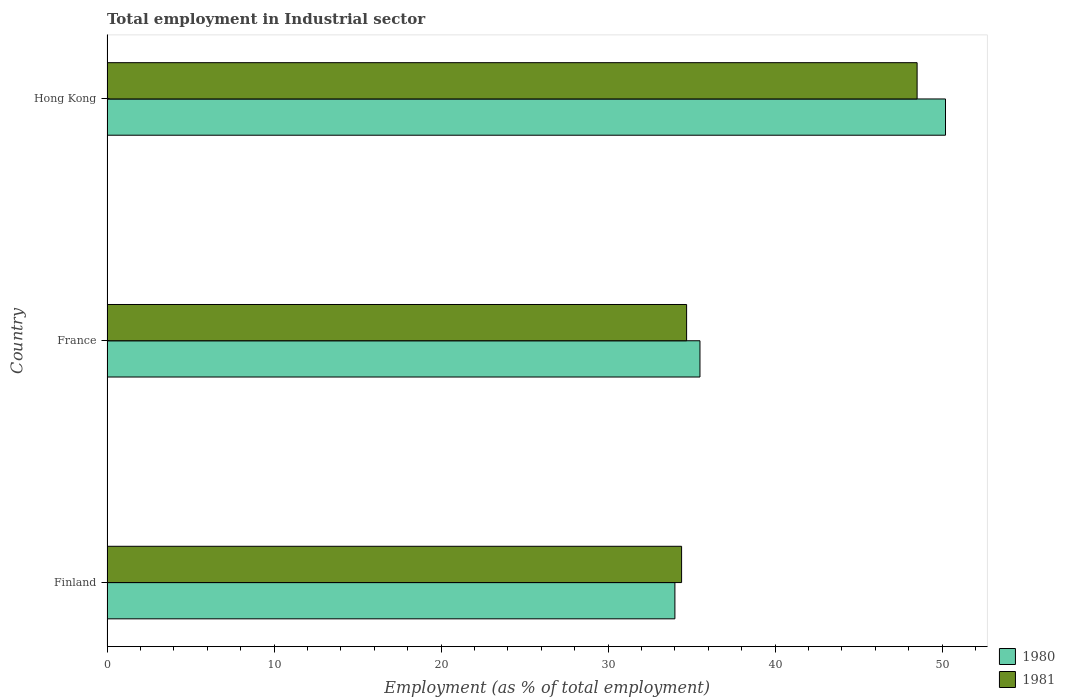How many different coloured bars are there?
Keep it short and to the point. 2. How many groups of bars are there?
Keep it short and to the point. 3. Are the number of bars per tick equal to the number of legend labels?
Ensure brevity in your answer.  Yes. Are the number of bars on each tick of the Y-axis equal?
Keep it short and to the point. Yes. How many bars are there on the 3rd tick from the top?
Make the answer very short. 2. What is the employment in industrial sector in 1981 in France?
Ensure brevity in your answer.  34.7. Across all countries, what is the maximum employment in industrial sector in 1980?
Provide a short and direct response. 50.2. Across all countries, what is the minimum employment in industrial sector in 1981?
Give a very brief answer. 34.4. In which country was the employment in industrial sector in 1981 maximum?
Your response must be concise. Hong Kong. In which country was the employment in industrial sector in 1981 minimum?
Provide a short and direct response. Finland. What is the total employment in industrial sector in 1980 in the graph?
Give a very brief answer. 119.7. What is the difference between the employment in industrial sector in 1980 in Finland and that in Hong Kong?
Offer a terse response. -16.2. What is the difference between the employment in industrial sector in 1981 in Hong Kong and the employment in industrial sector in 1980 in France?
Provide a short and direct response. 13. What is the average employment in industrial sector in 1981 per country?
Give a very brief answer. 39.2. What is the difference between the employment in industrial sector in 1981 and employment in industrial sector in 1980 in Hong Kong?
Give a very brief answer. -1.7. What is the ratio of the employment in industrial sector in 1981 in France to that in Hong Kong?
Provide a short and direct response. 0.72. Is the employment in industrial sector in 1980 in Finland less than that in Hong Kong?
Ensure brevity in your answer.  Yes. What is the difference between the highest and the second highest employment in industrial sector in 1981?
Your answer should be very brief. 13.8. What is the difference between the highest and the lowest employment in industrial sector in 1980?
Your response must be concise. 16.2. Is the sum of the employment in industrial sector in 1980 in Finland and Hong Kong greater than the maximum employment in industrial sector in 1981 across all countries?
Your answer should be compact. Yes. What does the 1st bar from the bottom in Hong Kong represents?
Offer a very short reply. 1980. How many bars are there?
Ensure brevity in your answer.  6. Are all the bars in the graph horizontal?
Make the answer very short. Yes. Where does the legend appear in the graph?
Keep it short and to the point. Bottom right. How many legend labels are there?
Your response must be concise. 2. How are the legend labels stacked?
Keep it short and to the point. Vertical. What is the title of the graph?
Ensure brevity in your answer.  Total employment in Industrial sector. What is the label or title of the X-axis?
Your response must be concise. Employment (as % of total employment). What is the label or title of the Y-axis?
Offer a very short reply. Country. What is the Employment (as % of total employment) of 1980 in Finland?
Keep it short and to the point. 34. What is the Employment (as % of total employment) in 1981 in Finland?
Your answer should be very brief. 34.4. What is the Employment (as % of total employment) of 1980 in France?
Provide a succinct answer. 35.5. What is the Employment (as % of total employment) of 1981 in France?
Your answer should be very brief. 34.7. What is the Employment (as % of total employment) in 1980 in Hong Kong?
Keep it short and to the point. 50.2. What is the Employment (as % of total employment) in 1981 in Hong Kong?
Make the answer very short. 48.5. Across all countries, what is the maximum Employment (as % of total employment) in 1980?
Provide a succinct answer. 50.2. Across all countries, what is the maximum Employment (as % of total employment) of 1981?
Ensure brevity in your answer.  48.5. Across all countries, what is the minimum Employment (as % of total employment) in 1980?
Your response must be concise. 34. Across all countries, what is the minimum Employment (as % of total employment) of 1981?
Provide a succinct answer. 34.4. What is the total Employment (as % of total employment) of 1980 in the graph?
Offer a terse response. 119.7. What is the total Employment (as % of total employment) of 1981 in the graph?
Ensure brevity in your answer.  117.6. What is the difference between the Employment (as % of total employment) of 1980 in Finland and that in France?
Offer a terse response. -1.5. What is the difference between the Employment (as % of total employment) of 1980 in Finland and that in Hong Kong?
Keep it short and to the point. -16.2. What is the difference between the Employment (as % of total employment) of 1981 in Finland and that in Hong Kong?
Offer a very short reply. -14.1. What is the difference between the Employment (as % of total employment) of 1980 in France and that in Hong Kong?
Your response must be concise. -14.7. What is the difference between the Employment (as % of total employment) in 1981 in France and that in Hong Kong?
Your answer should be very brief. -13.8. What is the difference between the Employment (as % of total employment) in 1980 in Finland and the Employment (as % of total employment) in 1981 in Hong Kong?
Ensure brevity in your answer.  -14.5. What is the average Employment (as % of total employment) of 1980 per country?
Ensure brevity in your answer.  39.9. What is the average Employment (as % of total employment) of 1981 per country?
Provide a succinct answer. 39.2. What is the difference between the Employment (as % of total employment) of 1980 and Employment (as % of total employment) of 1981 in France?
Keep it short and to the point. 0.8. What is the ratio of the Employment (as % of total employment) in 1980 in Finland to that in France?
Make the answer very short. 0.96. What is the ratio of the Employment (as % of total employment) in 1981 in Finland to that in France?
Your response must be concise. 0.99. What is the ratio of the Employment (as % of total employment) in 1980 in Finland to that in Hong Kong?
Give a very brief answer. 0.68. What is the ratio of the Employment (as % of total employment) in 1981 in Finland to that in Hong Kong?
Give a very brief answer. 0.71. What is the ratio of the Employment (as % of total employment) of 1980 in France to that in Hong Kong?
Keep it short and to the point. 0.71. What is the ratio of the Employment (as % of total employment) in 1981 in France to that in Hong Kong?
Provide a succinct answer. 0.72. What is the difference between the highest and the second highest Employment (as % of total employment) of 1981?
Ensure brevity in your answer.  13.8. What is the difference between the highest and the lowest Employment (as % of total employment) in 1980?
Your response must be concise. 16.2. What is the difference between the highest and the lowest Employment (as % of total employment) of 1981?
Keep it short and to the point. 14.1. 